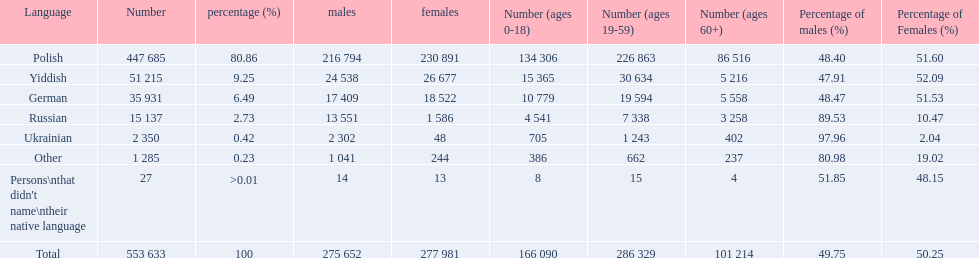What language makes a majority Polish. What the the total number of speakers? 553 633. 